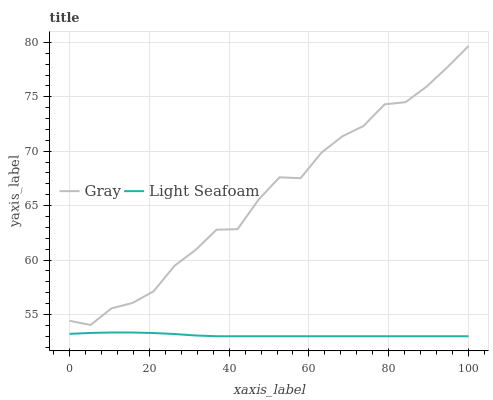Does Light Seafoam have the minimum area under the curve?
Answer yes or no. Yes. Does Gray have the maximum area under the curve?
Answer yes or no. Yes. Does Light Seafoam have the maximum area under the curve?
Answer yes or no. No. Is Light Seafoam the smoothest?
Answer yes or no. Yes. Is Gray the roughest?
Answer yes or no. Yes. Is Light Seafoam the roughest?
Answer yes or no. No. Does Light Seafoam have the lowest value?
Answer yes or no. Yes. Does Gray have the highest value?
Answer yes or no. Yes. Does Light Seafoam have the highest value?
Answer yes or no. No. Is Light Seafoam less than Gray?
Answer yes or no. Yes. Is Gray greater than Light Seafoam?
Answer yes or no. Yes. Does Light Seafoam intersect Gray?
Answer yes or no. No. 